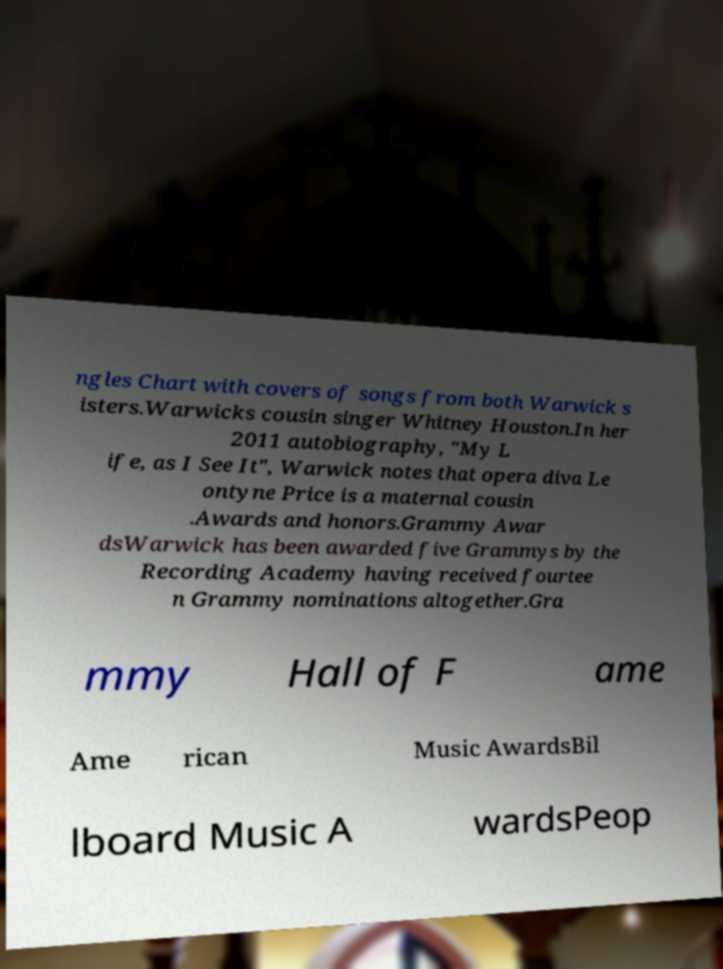Could you assist in decoding the text presented in this image and type it out clearly? ngles Chart with covers of songs from both Warwick s isters.Warwicks cousin singer Whitney Houston.In her 2011 autobiography, "My L ife, as I See It", Warwick notes that opera diva Le ontyne Price is a maternal cousin .Awards and honors.Grammy Awar dsWarwick has been awarded five Grammys by the Recording Academy having received fourtee n Grammy nominations altogether.Gra mmy Hall of F ame Ame rican Music AwardsBil lboard Music A wardsPeop 